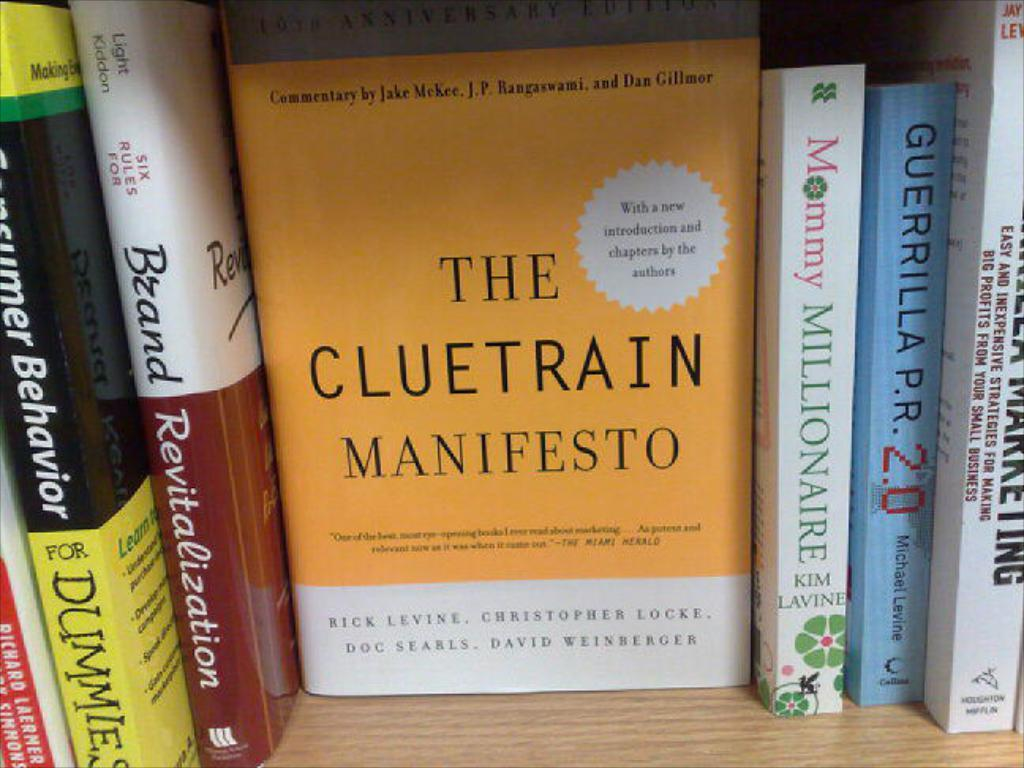<image>
Create a compact narrative representing the image presented. Yellow and white book titled The Cluetrain Manifesto in between other books. 